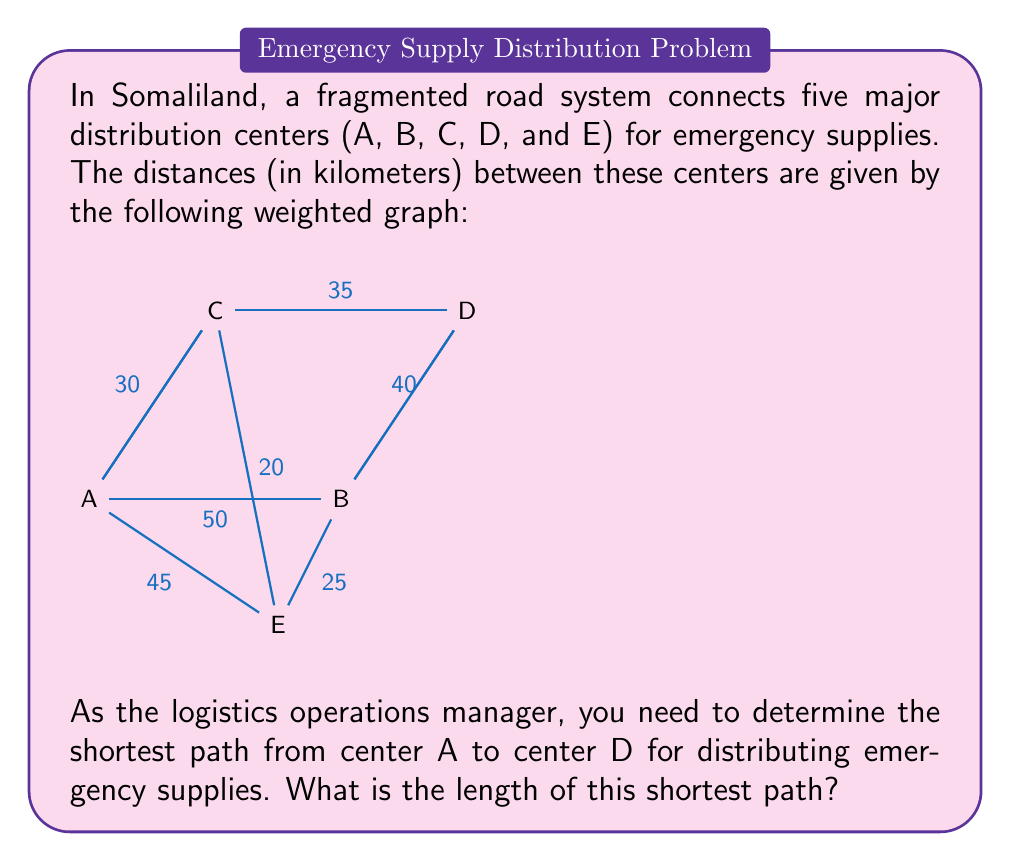Provide a solution to this math problem. To solve this problem, we can use Dijkstra's algorithm, which is an efficient method for finding the shortest path between nodes in a graph.

Let's apply Dijkstra's algorithm step by step:

1) Initialize:
   - Distance to A = 0
   - Distance to all other nodes = $\infty$
   - Set of unvisited nodes = {A, B, C, D, E}

2) Start from node A:
   - Update distances:
     B: min($\infty$, 0 + 50) = 50
     C: min($\infty$, 0 + 30) = 30
     E: min($\infty$, 0 + 45) = 45
   - Mark A as visited

3) Choose the node with the smallest distance (C):
   - Update distances:
     D: min($\infty$, 30 + 35) = 65
     E: min(45, 30 + 20) = 45
   - Mark C as visited

4) Choose the node with the smallest distance (E):
   - Update distances:
     B: min(50, 45 + 25) = 50
     D: min(65, 45 + $\infty$) = 65 (no direct path from E to D)
   - Mark E as visited

5) Choose the node with the smallest distance (B):
   - Update distances:
     D: min(65, 50 + 40) = 65
   - Mark B as visited

6) The only unvisited node left is D, with a distance of 65.

The shortest path from A to D is A → C → D, with a total distance of 65 km.
Answer: The length of the shortest path from center A to center D is 65 km. 